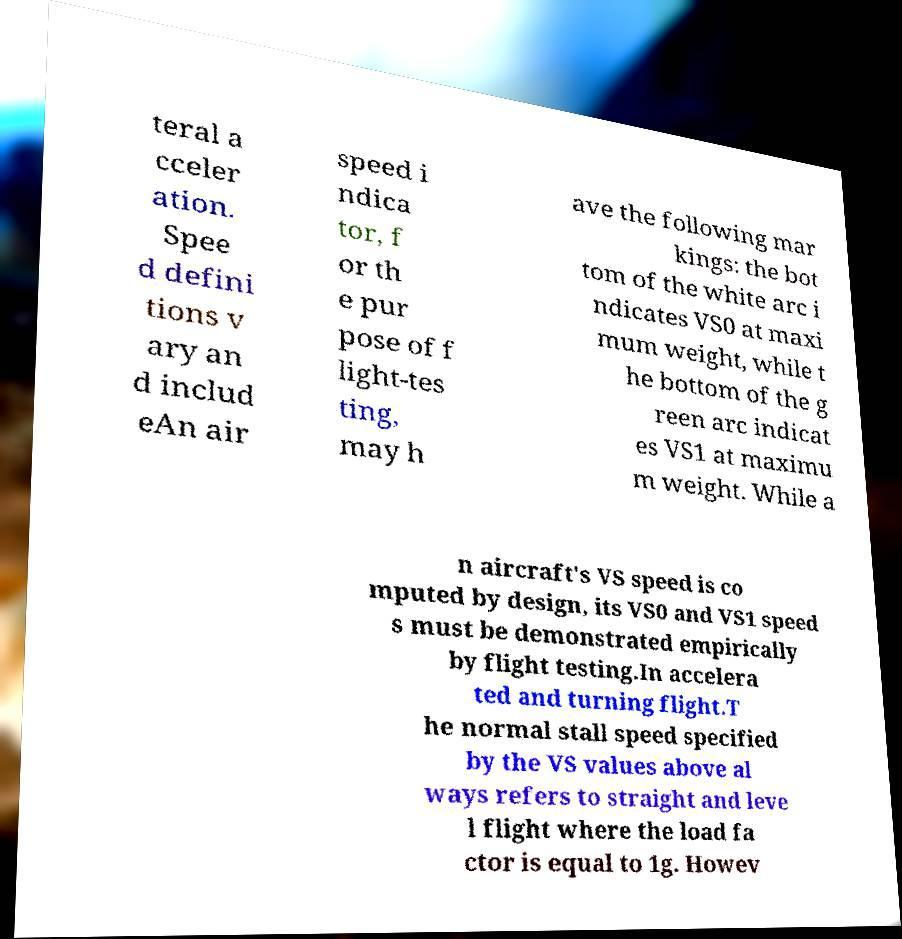Can you read and provide the text displayed in the image?This photo seems to have some interesting text. Can you extract and type it out for me? teral a cceler ation. Spee d defini tions v ary an d includ eAn air speed i ndica tor, f or th e pur pose of f light-tes ting, may h ave the following mar kings: the bot tom of the white arc i ndicates VS0 at maxi mum weight, while t he bottom of the g reen arc indicat es VS1 at maximu m weight. While a n aircraft's VS speed is co mputed by design, its VS0 and VS1 speed s must be demonstrated empirically by flight testing.In accelera ted and turning flight.T he normal stall speed specified by the VS values above al ways refers to straight and leve l flight where the load fa ctor is equal to 1g. Howev 